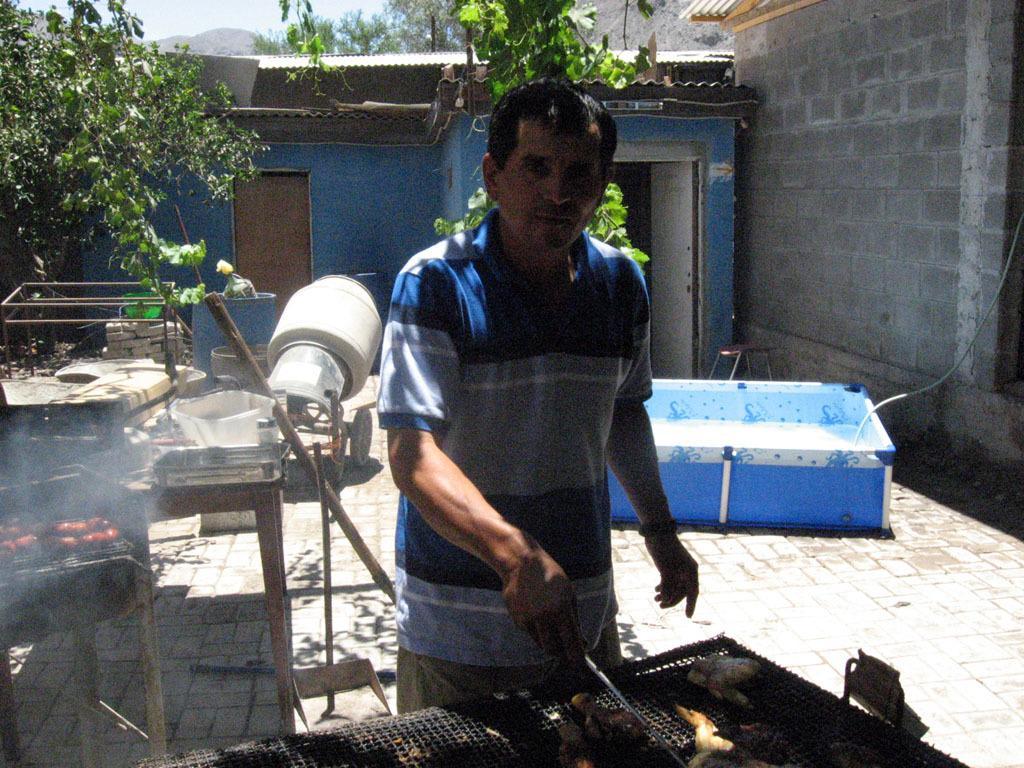How would you summarize this image in a sentence or two? There is a man standing and holding a stick,in front of him we can see food items on grills. In the background we can see house,wall,wooden stick,barrel,blue box,trees,rods,objects and sky. 